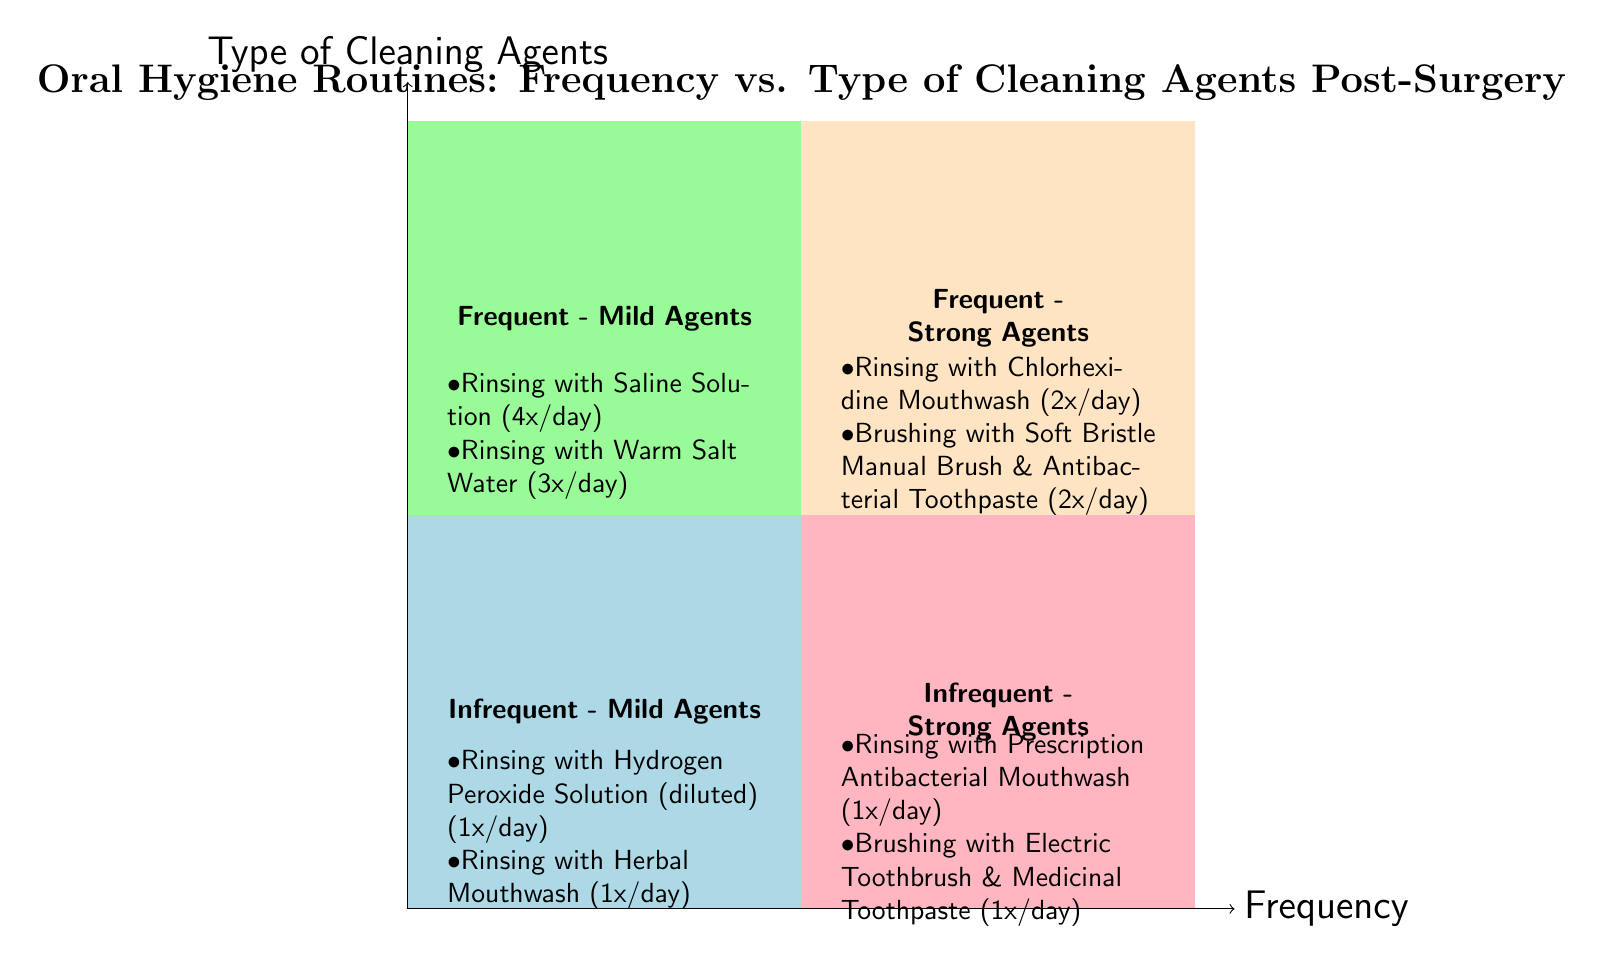What cleaning agents are used frequently with mild agents? The quadrant labeled "Frequent - Mild Agents" lists the cleaning types and specific agents. It includes "Rinsing with Saline Solution" (4 times per day) and "Rinsing with Warm Salt Water" (3 times per day).
Answer: Rinsing with Saline Solution, Rinsing with Warm Salt Water How many examples are provided in the "Frequent - Strong Agents" quadrant? This quadrant contains two examples: "Rinsing with Chlorhexidine Mouthwash" (2 times per day) and "Brushing with Soft Bristle Manual Brush with Antibacterial Toothpaste" (2 times per day). Therefore, the count is based on the list of examples displayed in the quadrant.
Answer: 2 What is the frequency of rinsing with Hydrogen Peroxide Solution (diluted)? Looking at the "Infrequent - Mild Agents" quadrant, it lists "Rinsing with Hydrogen Peroxide Solution (diluted)" which occurs 1 time per day. This is deduced from the frequency data associated with that example in the respective quadrant.
Answer: 1 Which quadrant contains the strongest agents? The quadrants labeled "Frequent - Strong Agents" and "Infrequent - Strong Agents" contain the strongest agents. To identify them, you check the examples provided. "Chlorhexidine Mouthwash" and "Prescription Antibacterial Mouthwash" are the cleaning agents in those quadrants.
Answer: Frequent - Strong Agents, Infrequent - Strong Agents What is the cleaning routine for infrequent use of mild agents? The "Infrequent - Mild Agents" quadrant shows two examples: "Rinsing with Hydrogen Peroxide Solution (diluted)" and "Rinsing with Herbal Mouthwash," both used 1 time per day. You identify this quadrant and its respective entries to answer the question succinctly.
Answer: Rinsing with Hydrogen Peroxide Solution, Rinsing with Herbal Mouthwash Which cleaning procedure is listed under the "Infrequent - Strong Agents" quadrant? This quadrant includes examples that highlight certain cleaning procedures such as "Rinsing" and "Brushing." By looking specifically at the quadrant, you find "Rinsing with Prescription Antibacterial Mouthwash" and "Brushing with Electric Toothbrush & Medicinal Toothpaste" as the mentioned procedures.
Answer: Rinsing with Prescription Antibacterial Mouthwash, Brushing with Electric Toothbrush & Medicinal Toothpaste 